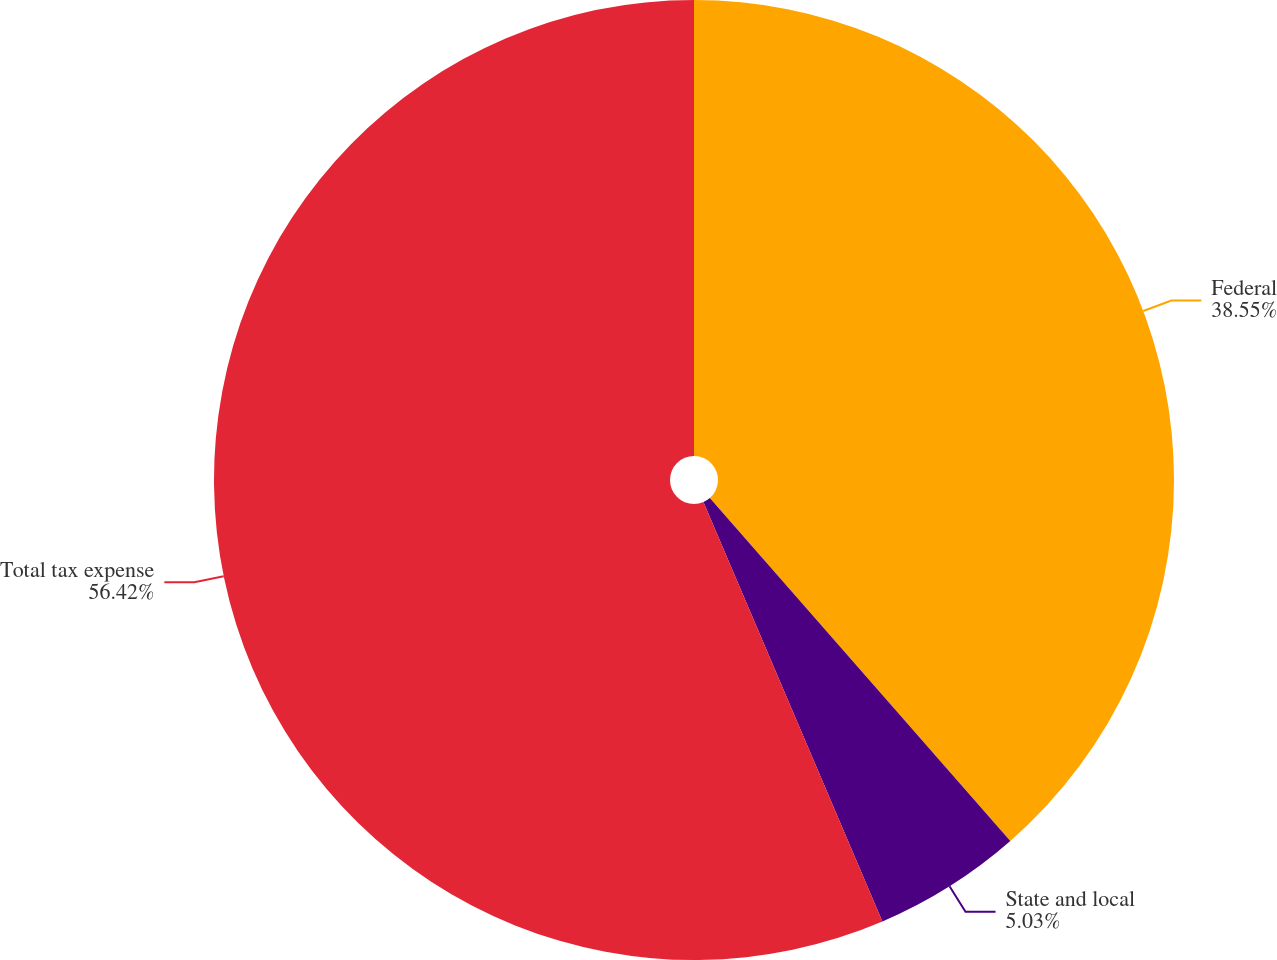<chart> <loc_0><loc_0><loc_500><loc_500><pie_chart><fcel>Federal<fcel>State and local<fcel>Total tax expense<nl><fcel>38.55%<fcel>5.03%<fcel>56.42%<nl></chart> 